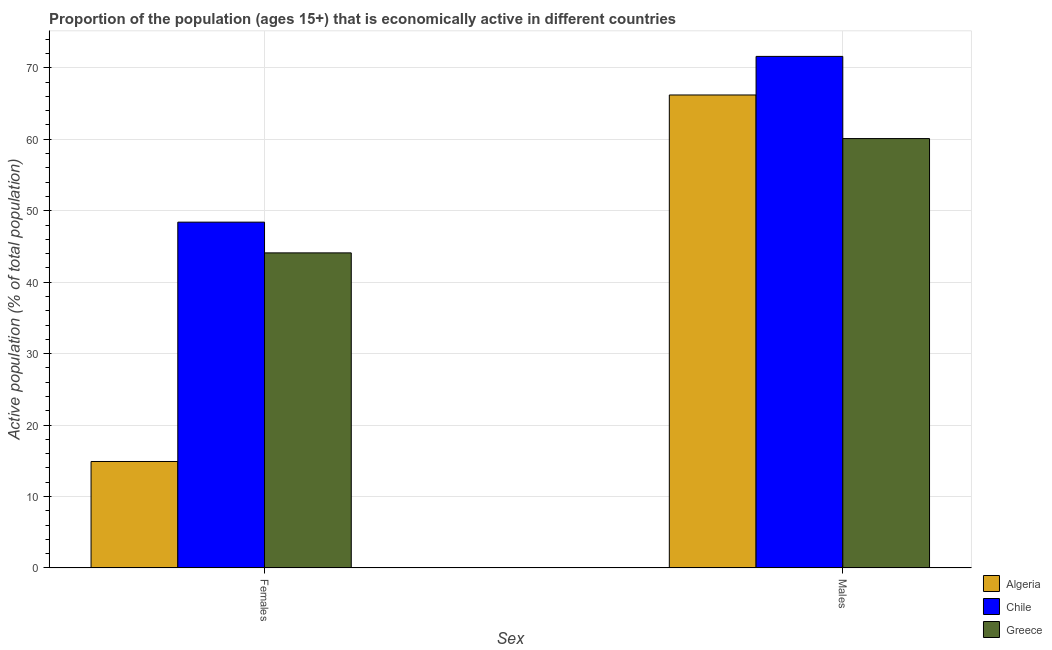How many groups of bars are there?
Offer a terse response. 2. Are the number of bars per tick equal to the number of legend labels?
Offer a very short reply. Yes. How many bars are there on the 1st tick from the right?
Provide a short and direct response. 3. What is the label of the 2nd group of bars from the left?
Make the answer very short. Males. What is the percentage of economically active female population in Greece?
Offer a terse response. 44.1. Across all countries, what is the maximum percentage of economically active female population?
Offer a very short reply. 48.4. Across all countries, what is the minimum percentage of economically active male population?
Offer a very short reply. 60.1. In which country was the percentage of economically active female population minimum?
Offer a terse response. Algeria. What is the total percentage of economically active female population in the graph?
Offer a very short reply. 107.4. What is the difference between the percentage of economically active female population in Greece and that in Algeria?
Your response must be concise. 29.2. What is the difference between the percentage of economically active male population in Algeria and the percentage of economically active female population in Chile?
Make the answer very short. 17.8. What is the average percentage of economically active male population per country?
Ensure brevity in your answer.  65.97. In how many countries, is the percentage of economically active male population greater than 10 %?
Ensure brevity in your answer.  3. What is the ratio of the percentage of economically active male population in Chile to that in Greece?
Provide a short and direct response. 1.19. In how many countries, is the percentage of economically active male population greater than the average percentage of economically active male population taken over all countries?
Offer a terse response. 2. What does the 1st bar from the left in Males represents?
Provide a succinct answer. Algeria. What does the 1st bar from the right in Males represents?
Your answer should be compact. Greece. How many bars are there?
Offer a terse response. 6. Are the values on the major ticks of Y-axis written in scientific E-notation?
Ensure brevity in your answer.  No. Does the graph contain any zero values?
Your answer should be compact. No. What is the title of the graph?
Provide a short and direct response. Proportion of the population (ages 15+) that is economically active in different countries. What is the label or title of the X-axis?
Keep it short and to the point. Sex. What is the label or title of the Y-axis?
Give a very brief answer. Active population (% of total population). What is the Active population (% of total population) in Algeria in Females?
Make the answer very short. 14.9. What is the Active population (% of total population) of Chile in Females?
Keep it short and to the point. 48.4. What is the Active population (% of total population) of Greece in Females?
Ensure brevity in your answer.  44.1. What is the Active population (% of total population) of Algeria in Males?
Make the answer very short. 66.2. What is the Active population (% of total population) in Chile in Males?
Make the answer very short. 71.6. What is the Active population (% of total population) in Greece in Males?
Provide a succinct answer. 60.1. Across all Sex, what is the maximum Active population (% of total population) of Algeria?
Your response must be concise. 66.2. Across all Sex, what is the maximum Active population (% of total population) of Chile?
Provide a short and direct response. 71.6. Across all Sex, what is the maximum Active population (% of total population) in Greece?
Offer a terse response. 60.1. Across all Sex, what is the minimum Active population (% of total population) of Algeria?
Ensure brevity in your answer.  14.9. Across all Sex, what is the minimum Active population (% of total population) in Chile?
Your response must be concise. 48.4. Across all Sex, what is the minimum Active population (% of total population) of Greece?
Ensure brevity in your answer.  44.1. What is the total Active population (% of total population) of Algeria in the graph?
Offer a terse response. 81.1. What is the total Active population (% of total population) in Chile in the graph?
Offer a terse response. 120. What is the total Active population (% of total population) in Greece in the graph?
Make the answer very short. 104.2. What is the difference between the Active population (% of total population) of Algeria in Females and that in Males?
Make the answer very short. -51.3. What is the difference between the Active population (% of total population) in Chile in Females and that in Males?
Offer a terse response. -23.2. What is the difference between the Active population (% of total population) in Algeria in Females and the Active population (% of total population) in Chile in Males?
Keep it short and to the point. -56.7. What is the difference between the Active population (% of total population) of Algeria in Females and the Active population (% of total population) of Greece in Males?
Provide a short and direct response. -45.2. What is the average Active population (% of total population) of Algeria per Sex?
Keep it short and to the point. 40.55. What is the average Active population (% of total population) in Chile per Sex?
Keep it short and to the point. 60. What is the average Active population (% of total population) in Greece per Sex?
Ensure brevity in your answer.  52.1. What is the difference between the Active population (% of total population) in Algeria and Active population (% of total population) in Chile in Females?
Your answer should be compact. -33.5. What is the difference between the Active population (% of total population) of Algeria and Active population (% of total population) of Greece in Females?
Ensure brevity in your answer.  -29.2. What is the difference between the Active population (% of total population) of Chile and Active population (% of total population) of Greece in Females?
Your response must be concise. 4.3. What is the difference between the Active population (% of total population) in Chile and Active population (% of total population) in Greece in Males?
Ensure brevity in your answer.  11.5. What is the ratio of the Active population (% of total population) of Algeria in Females to that in Males?
Give a very brief answer. 0.23. What is the ratio of the Active population (% of total population) in Chile in Females to that in Males?
Offer a terse response. 0.68. What is the ratio of the Active population (% of total population) in Greece in Females to that in Males?
Your response must be concise. 0.73. What is the difference between the highest and the second highest Active population (% of total population) of Algeria?
Your answer should be very brief. 51.3. What is the difference between the highest and the second highest Active population (% of total population) of Chile?
Offer a very short reply. 23.2. What is the difference between the highest and the second highest Active population (% of total population) of Greece?
Ensure brevity in your answer.  16. What is the difference between the highest and the lowest Active population (% of total population) in Algeria?
Your answer should be compact. 51.3. What is the difference between the highest and the lowest Active population (% of total population) of Chile?
Ensure brevity in your answer.  23.2. 